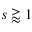<formula> <loc_0><loc_0><loc_500><loc_500>s \gtrapprox 1</formula> 